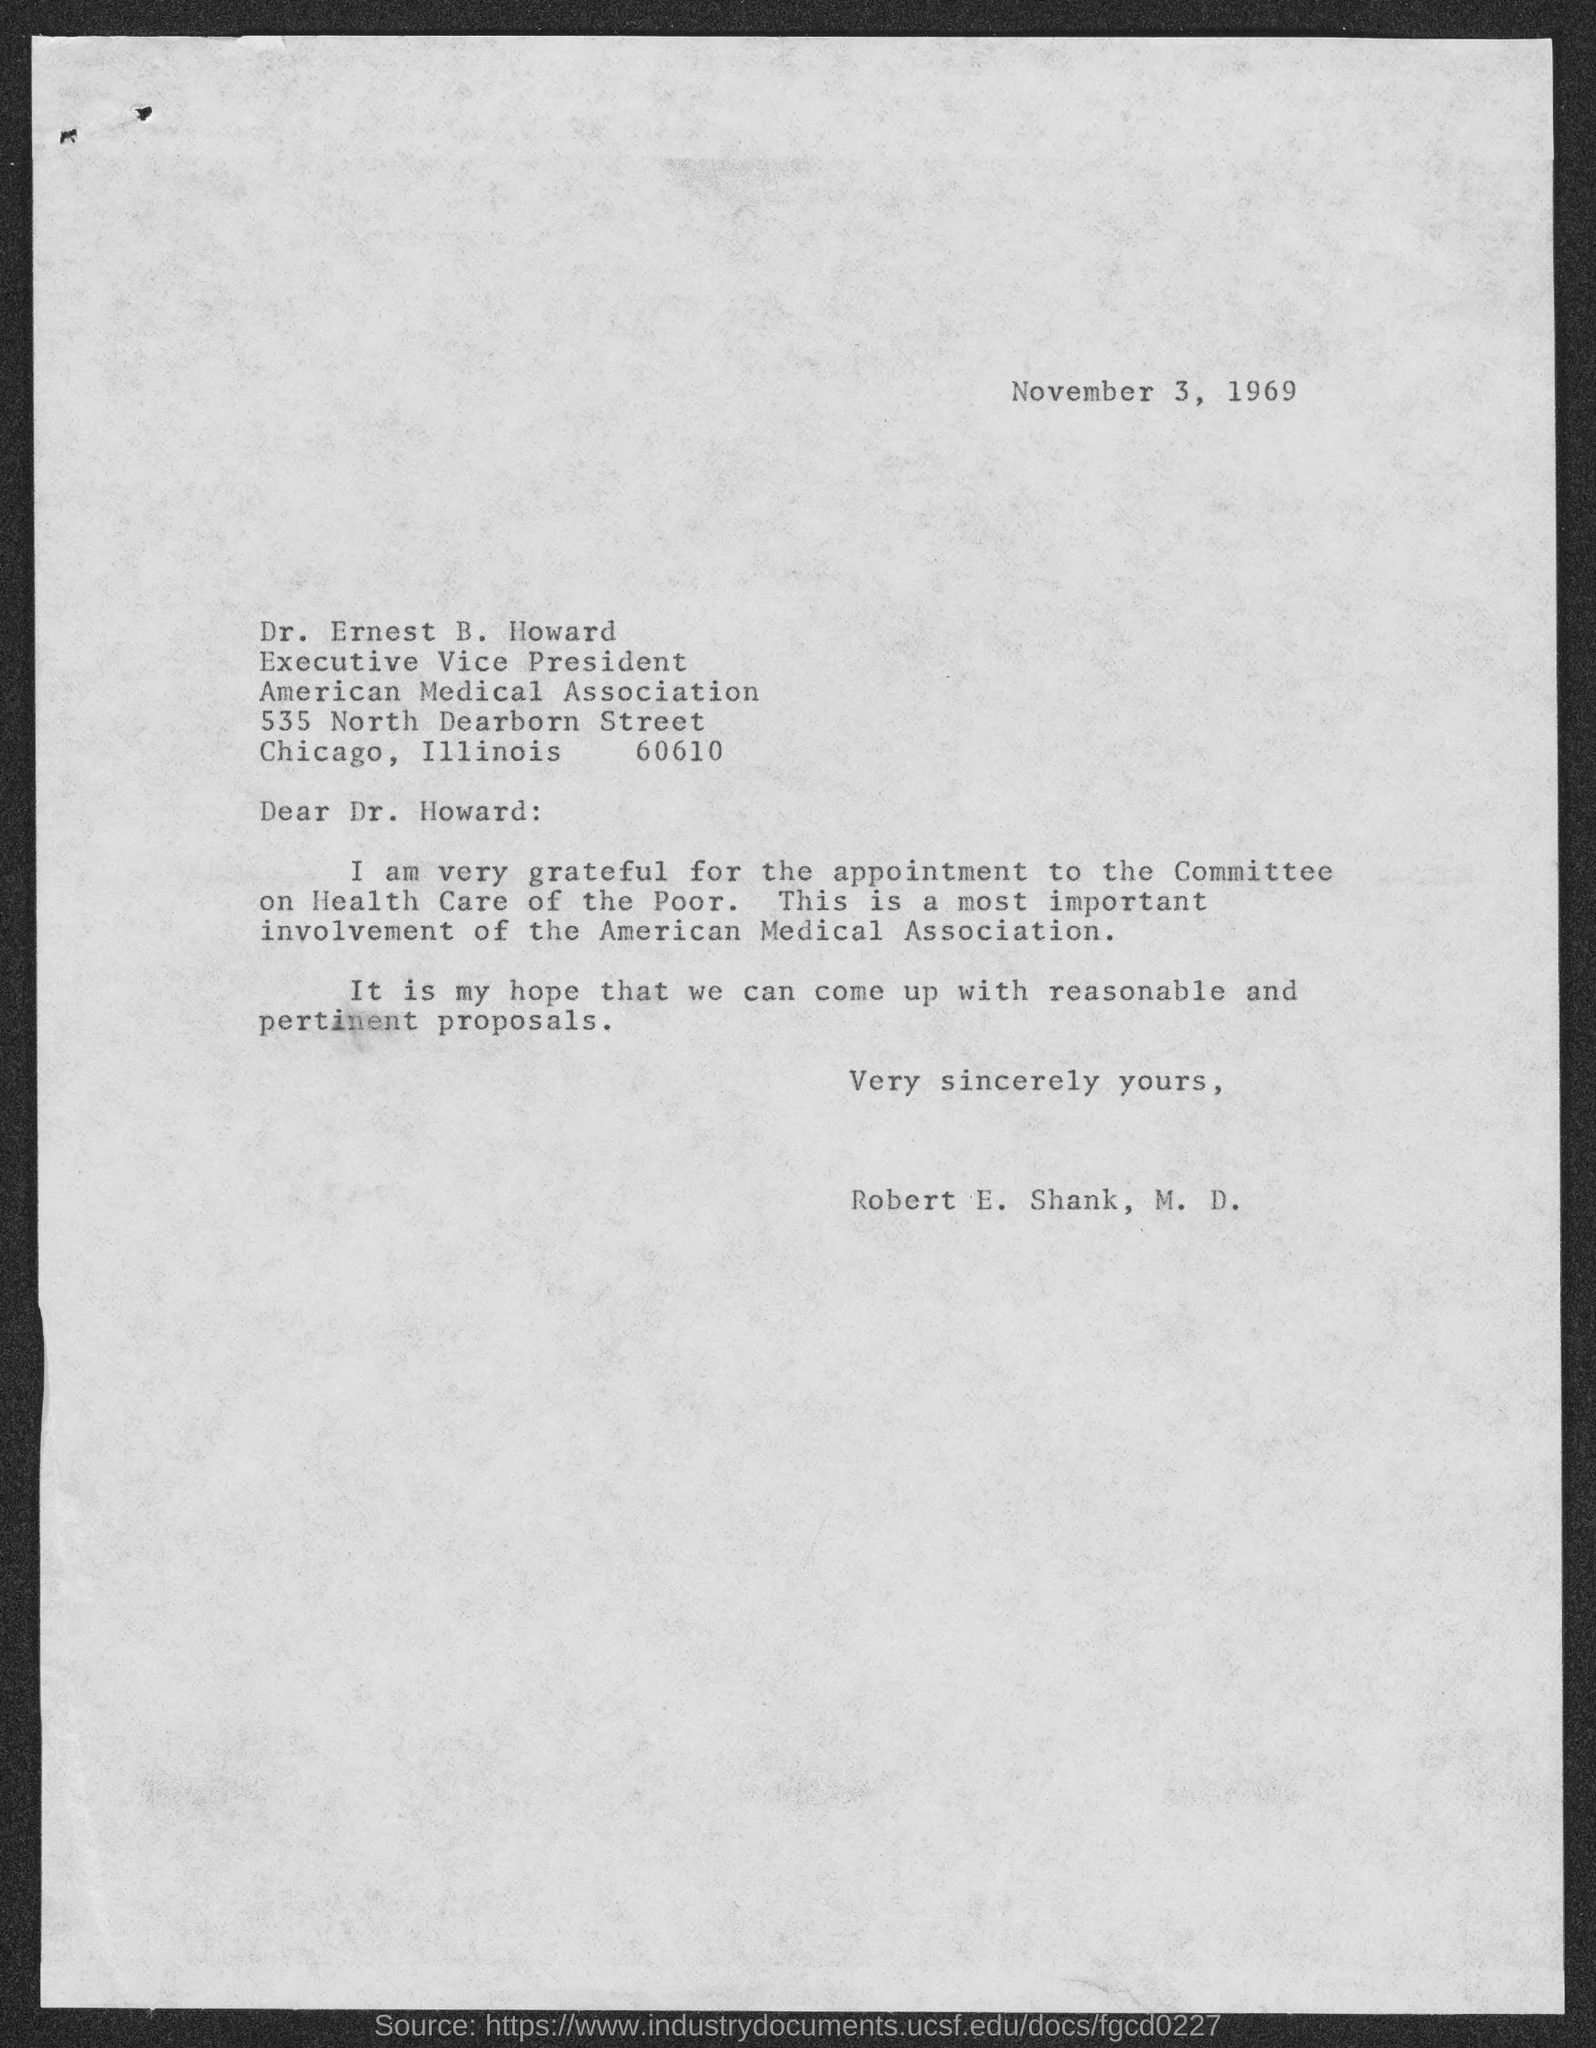Highlight a few significant elements in this photo. The recipient of this letter is Dr. Ernest B. Howard. The letter was written by Robert E. Shank, M.D. Dr. Ernest B. Howard is the executive vice president of the American Medical Association. The letter is dated on November 3, 1969. 